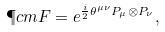Convert formula to latex. <formula><loc_0><loc_0><loc_500><loc_500>\P c m { F } = e ^ { \frac { i } 2 \theta ^ { \mu \nu } P _ { \mu } \otimes P _ { \nu } } ,</formula> 